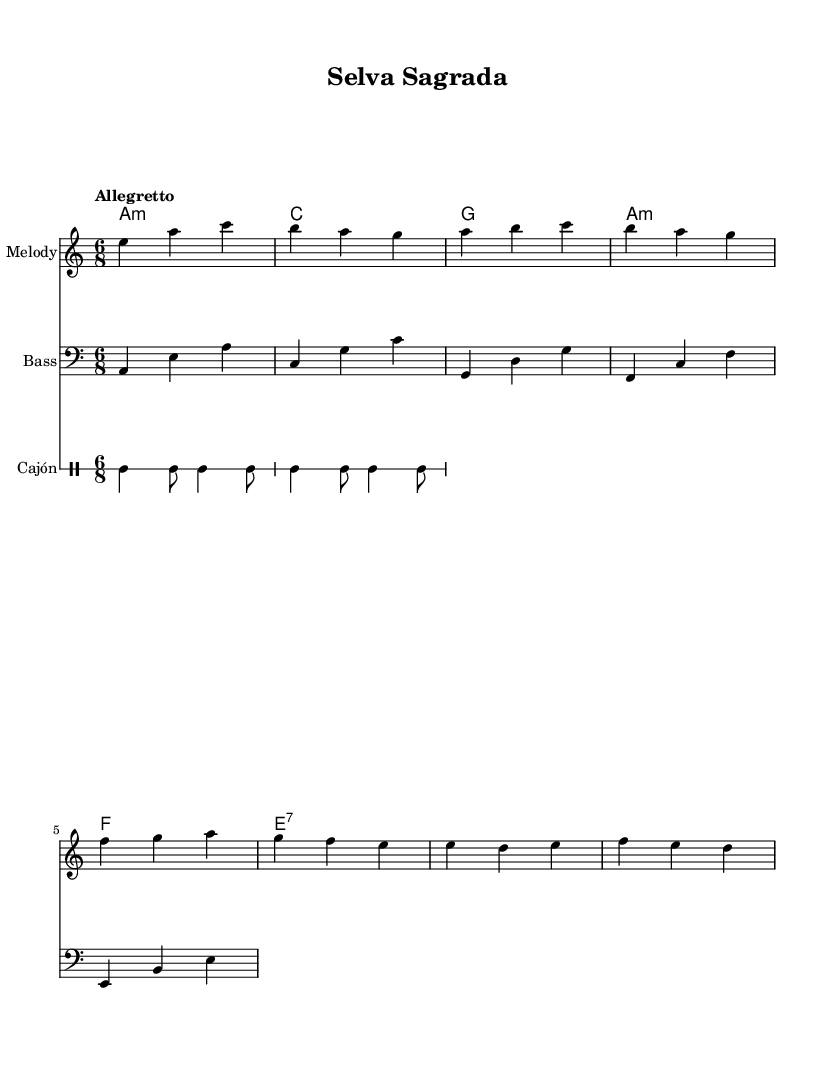What is the key signature of this music? The key signature is A minor, which has no sharps or flats.
Answer: A minor What is the time signature of this piece? The time signature is indicated as 6/8, meaning there are six eighth notes per measure.
Answer: 6/8 What is the tempo marking for this music? The tempo marking is "Allegretto," indicating a moderately fast tempo.
Answer: Allegretto What instruments are featured in this musical score? The score features a melody played by acoustic guitar (nylon), a bass, and cajón for percussion.
Answer: Acoustic guitar (nylon), bass, cajón How many measures are in the melody section? There are 4 measures in the melody section, as indicated by the grouping of notes.
Answer: 4 What is the relationship between the harmonies and the melody? The harmonies provide a harmonic foundation for the melody, enhancing its emotional expression and supporting its structure.
Answer: Harmonic foundation Is the cajón percussion pattern consistent throughout the score? The cajón pattern consists of repeated rhythmic phrases in a consistent structure, creating a stable rhythmic backdrop.
Answer: Yes 